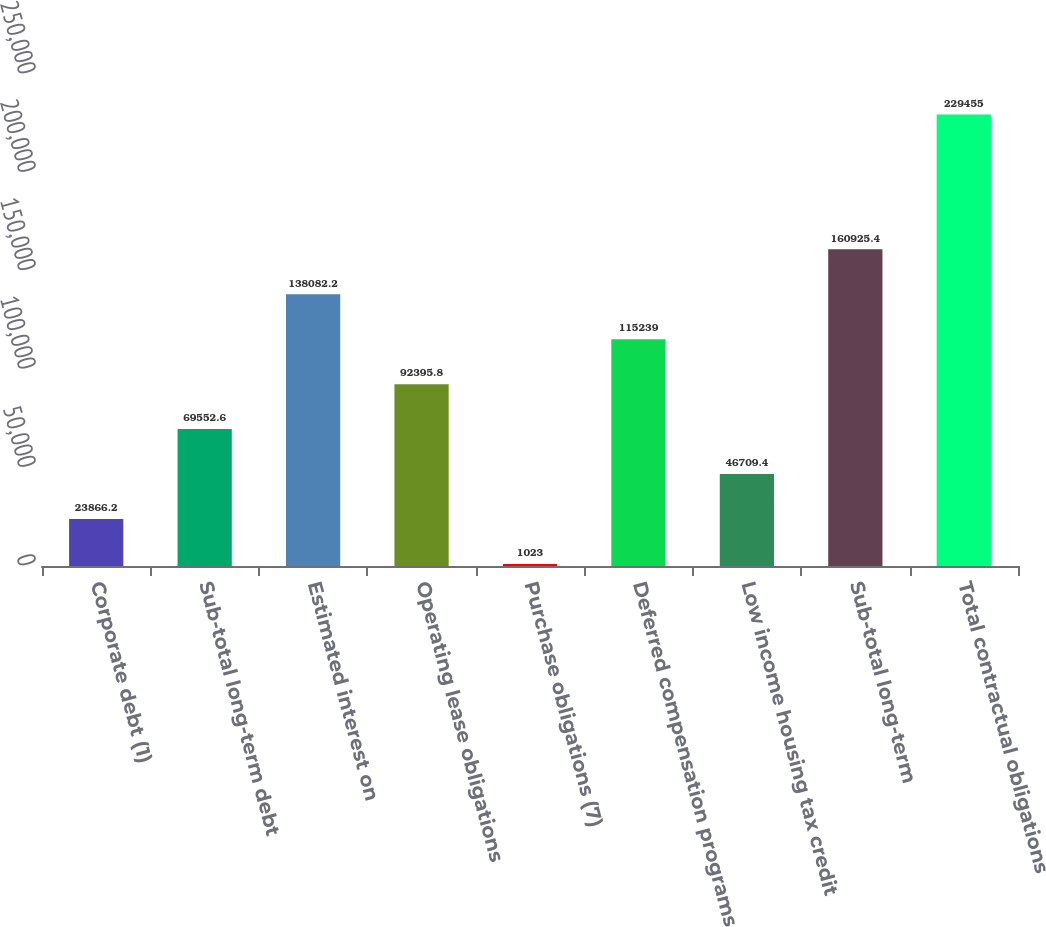Convert chart to OTSL. <chart><loc_0><loc_0><loc_500><loc_500><bar_chart><fcel>Corporate debt (1)<fcel>Sub-total long-term debt<fcel>Estimated interest on<fcel>Operating lease obligations<fcel>Purchase obligations (7)<fcel>Deferred compensation programs<fcel>Low income housing tax credit<fcel>Sub-total long-term<fcel>Total contractual obligations<nl><fcel>23866.2<fcel>69552.6<fcel>138082<fcel>92395.8<fcel>1023<fcel>115239<fcel>46709.4<fcel>160925<fcel>229455<nl></chart> 